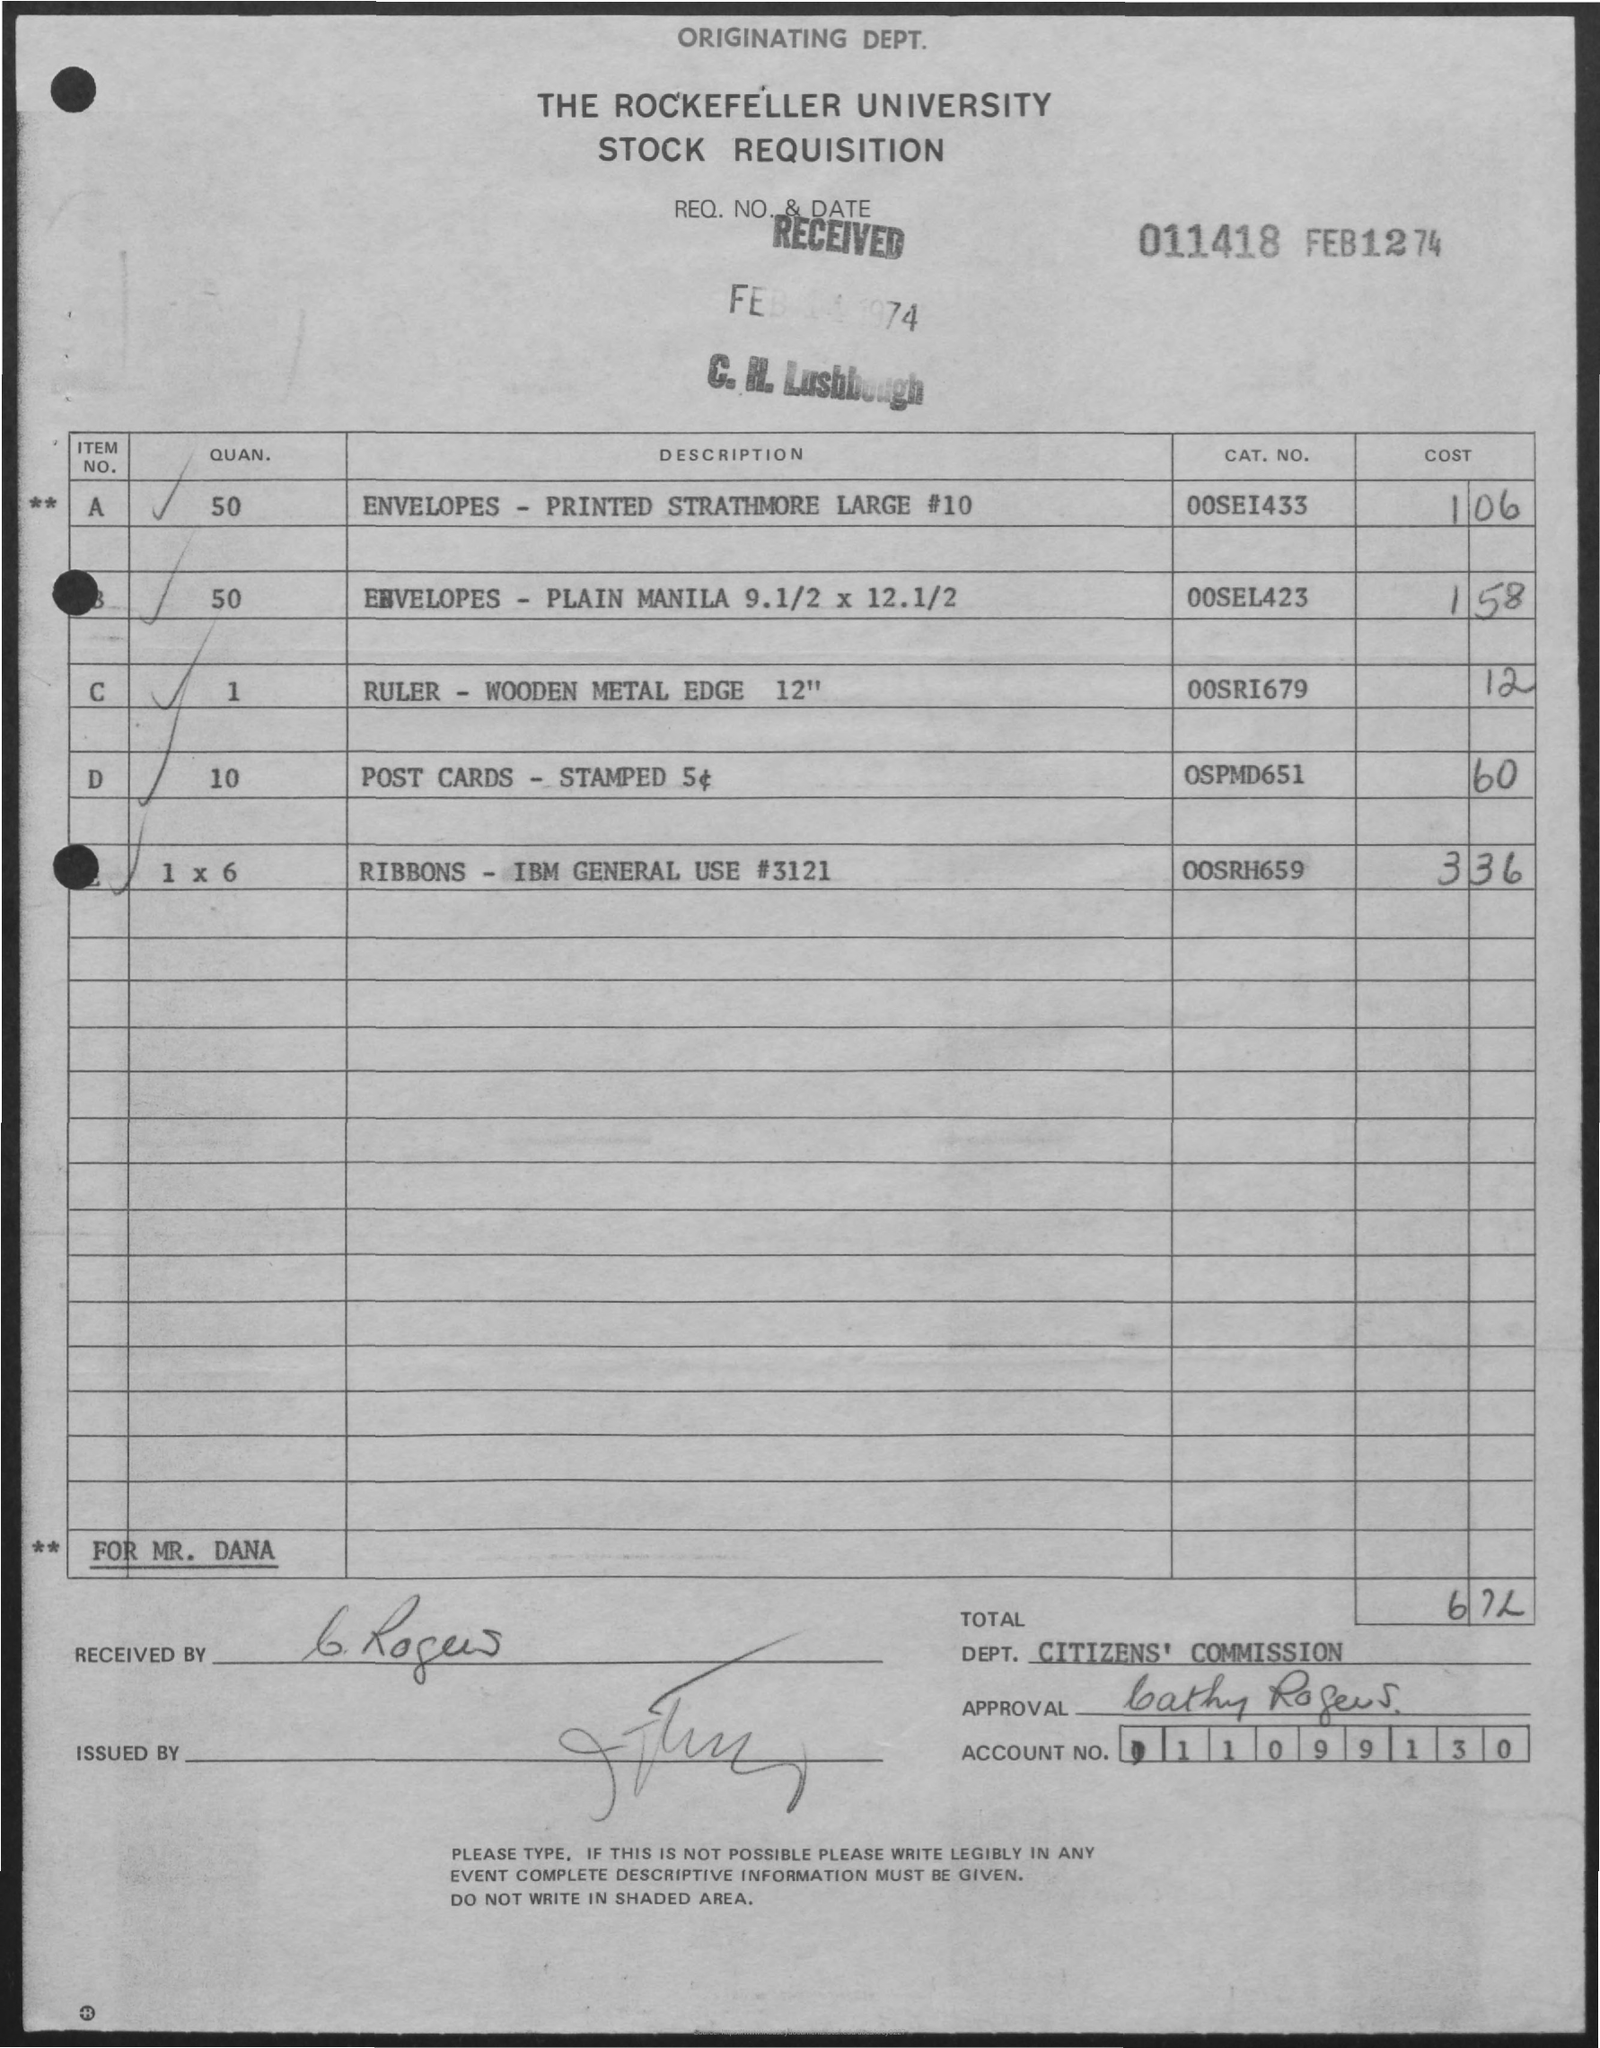What is the name of the university mentioned in the given page ?
Offer a very short reply. The rockefeller university. What is the quan. of envelopes - printed strathmore large # 10 as mentioned in the given page ?
Offer a terse response. 50. What is the cost of envelopes- plain manila as mentioned in the given page ?
Your answer should be compact. 1.58. What is the cost of post cards - stamped as mentioned in the given page ?
Make the answer very short. .60. What is the cat. no. for the ribbons - ibm  general use # 3121 ?
Give a very brief answer. 00SRH659. What is the cost of ruler mentioned in the given page ?
Give a very brief answer. .12. What is the req. no & date mentioned in the given page ?
Your response must be concise. 011418  feb 12 74. What is the cost of ribbons mentioned in the given page ?
Provide a short and direct response. 3 36. 